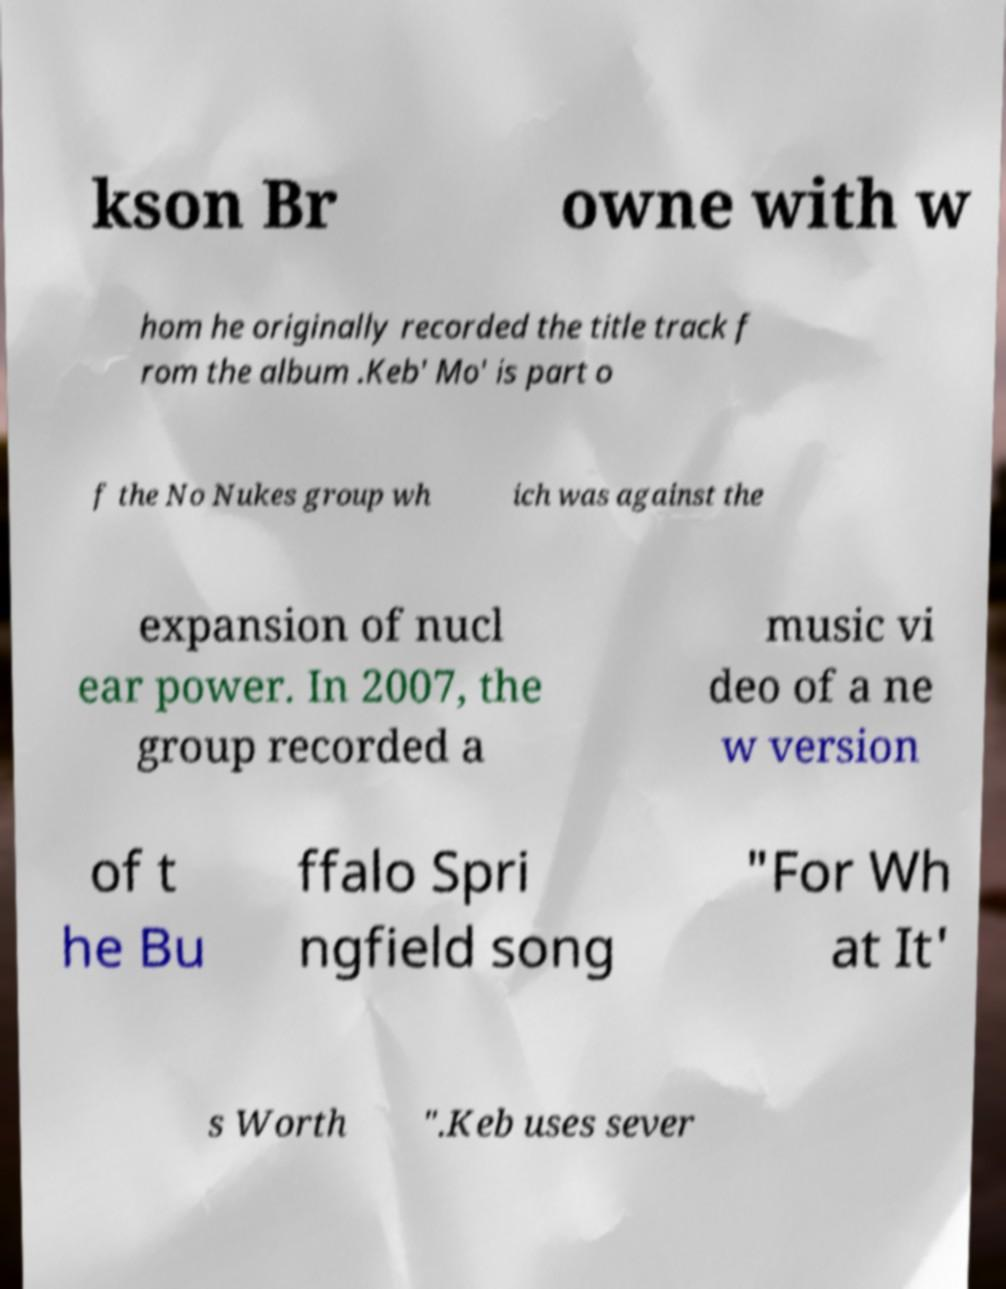Could you assist in decoding the text presented in this image and type it out clearly? kson Br owne with w hom he originally recorded the title track f rom the album .Keb' Mo' is part o f the No Nukes group wh ich was against the expansion of nucl ear power. In 2007, the group recorded a music vi deo of a ne w version of t he Bu ffalo Spri ngfield song "For Wh at It' s Worth ".Keb uses sever 